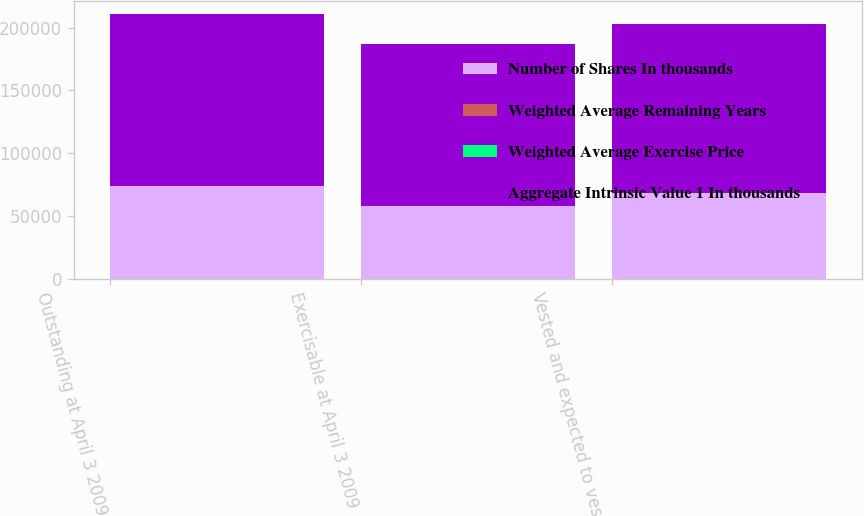Convert chart. <chart><loc_0><loc_0><loc_500><loc_500><stacked_bar_chart><ecel><fcel>Outstanding at April 3 2009<fcel>Exercisable at April 3 2009<fcel>Vested and expected to vest at<nl><fcel>Number of Shares In thousands<fcel>74023<fcel>57611<fcel>68472<nl><fcel>Weighted Average Remaining Years<fcel>18.61<fcel>18.65<fcel>18.62<nl><fcel>Weighted Average Exercise Price<fcel>3.96<fcel>3.57<fcel>3.86<nl><fcel>Aggregate Intrinsic Value 1 In thousands<fcel>136615<fcel>129608<fcel>134250<nl></chart> 